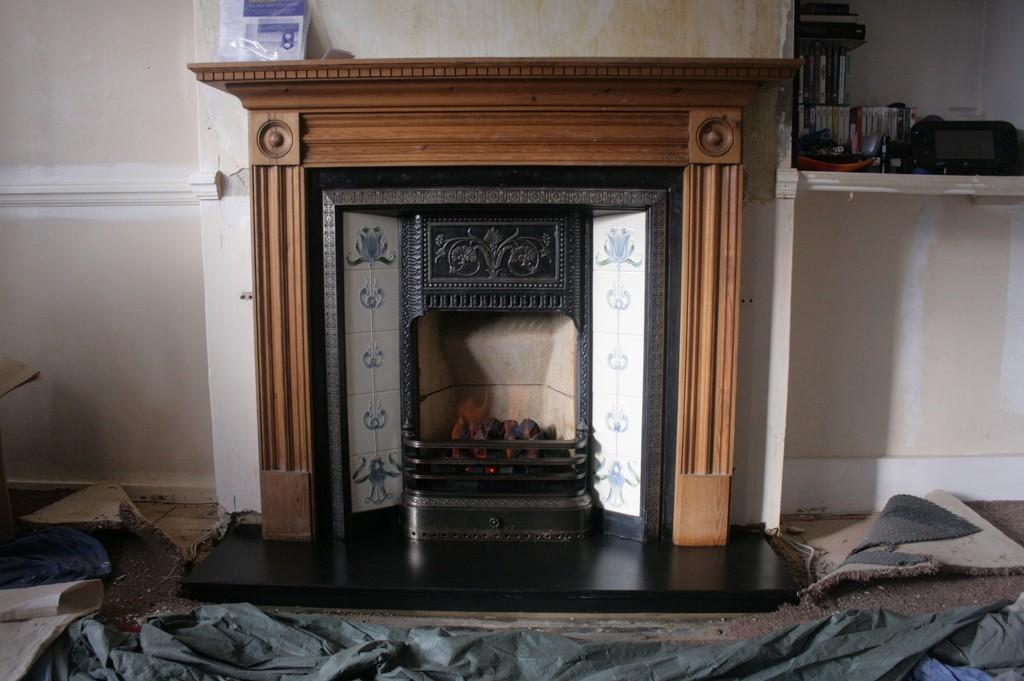What type of structure is present on the wall in the image? There is a fireplace with a wooden frame on the wall in the image. What can be seen hanging on the wall above the fireplace? The provided facts do not mention any items hanging on the wall above the fireplace. What is placed on the rack in the image? The facts do not specify what items are placed on the rack. What is on the floor in front of the fireplace? There is a floor mat on the floor in the image. What grade is the student receiving for their performance in the battle depicted in the image? There is no battle or student present in the image; it features a wall with a fireplace and a floor mat. 